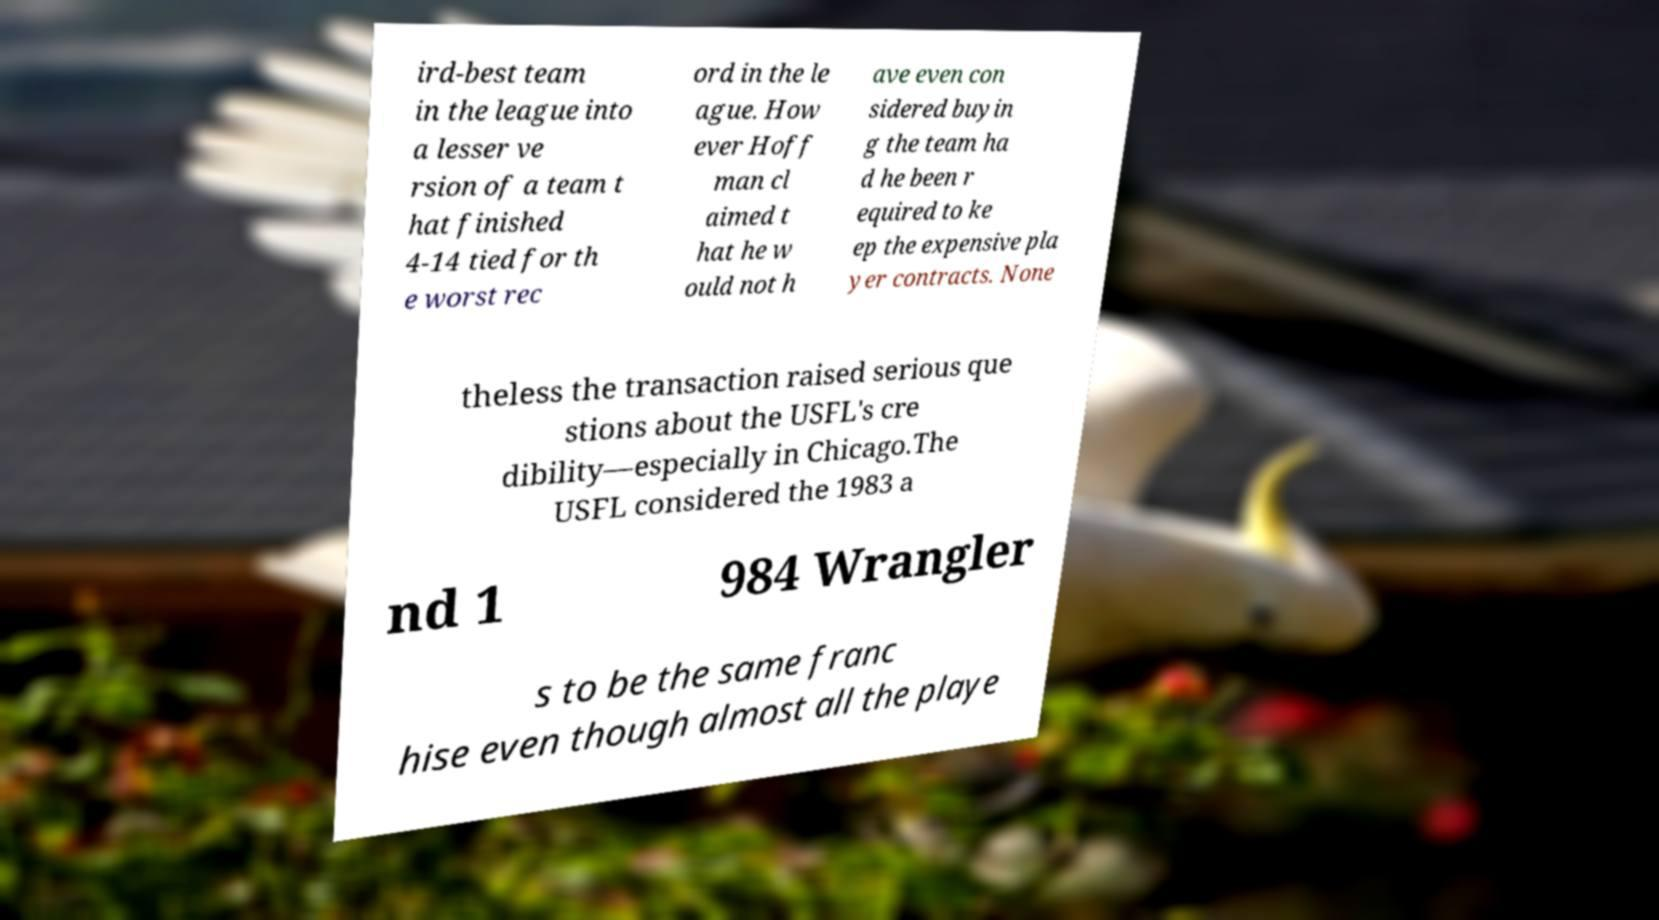Can you read and provide the text displayed in the image?This photo seems to have some interesting text. Can you extract and type it out for me? ird-best team in the league into a lesser ve rsion of a team t hat finished 4-14 tied for th e worst rec ord in the le ague. How ever Hoff man cl aimed t hat he w ould not h ave even con sidered buyin g the team ha d he been r equired to ke ep the expensive pla yer contracts. None theless the transaction raised serious que stions about the USFL's cre dibility—especially in Chicago.The USFL considered the 1983 a nd 1 984 Wrangler s to be the same franc hise even though almost all the playe 